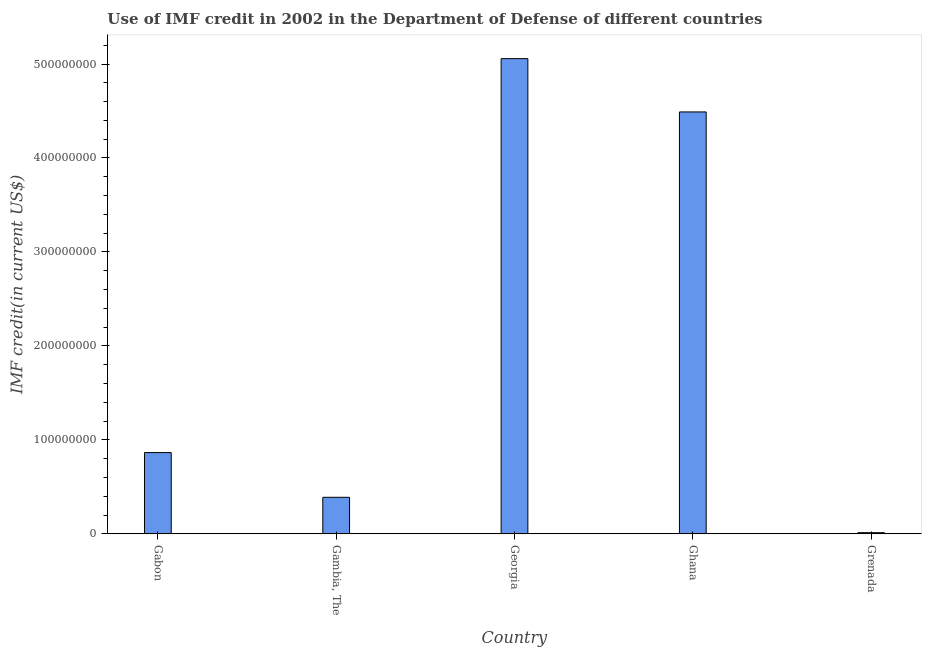Does the graph contain any zero values?
Make the answer very short. No. What is the title of the graph?
Give a very brief answer. Use of IMF credit in 2002 in the Department of Defense of different countries. What is the label or title of the X-axis?
Provide a succinct answer. Country. What is the label or title of the Y-axis?
Your answer should be compact. IMF credit(in current US$). What is the use of imf credit in dod in Grenada?
Provide a short and direct response. 1.26e+06. Across all countries, what is the maximum use of imf credit in dod?
Provide a short and direct response. 5.06e+08. Across all countries, what is the minimum use of imf credit in dod?
Your answer should be very brief. 1.26e+06. In which country was the use of imf credit in dod maximum?
Offer a terse response. Georgia. In which country was the use of imf credit in dod minimum?
Give a very brief answer. Grenada. What is the sum of the use of imf credit in dod?
Give a very brief answer. 1.08e+09. What is the difference between the use of imf credit in dod in Ghana and Grenada?
Make the answer very short. 4.48e+08. What is the average use of imf credit in dod per country?
Give a very brief answer. 2.16e+08. What is the median use of imf credit in dod?
Your answer should be compact. 8.65e+07. In how many countries, is the use of imf credit in dod greater than 320000000 US$?
Your response must be concise. 2. What is the ratio of the use of imf credit in dod in Gabon to that in Grenada?
Keep it short and to the point. 68.43. Is the use of imf credit in dod in Gabon less than that in Grenada?
Keep it short and to the point. No. What is the difference between the highest and the second highest use of imf credit in dod?
Provide a short and direct response. 5.67e+07. Is the sum of the use of imf credit in dod in Gambia, The and Ghana greater than the maximum use of imf credit in dod across all countries?
Your answer should be compact. No. What is the difference between the highest and the lowest use of imf credit in dod?
Provide a short and direct response. 5.04e+08. In how many countries, is the use of imf credit in dod greater than the average use of imf credit in dod taken over all countries?
Offer a terse response. 2. How many countries are there in the graph?
Give a very brief answer. 5. Are the values on the major ticks of Y-axis written in scientific E-notation?
Ensure brevity in your answer.  No. What is the IMF credit(in current US$) of Gabon?
Your answer should be compact. 8.65e+07. What is the IMF credit(in current US$) of Gambia, The?
Provide a short and direct response. 3.89e+07. What is the IMF credit(in current US$) of Georgia?
Ensure brevity in your answer.  5.06e+08. What is the IMF credit(in current US$) of Ghana?
Provide a succinct answer. 4.49e+08. What is the IMF credit(in current US$) in Grenada?
Your answer should be very brief. 1.26e+06. What is the difference between the IMF credit(in current US$) in Gabon and Gambia, The?
Provide a succinct answer. 4.76e+07. What is the difference between the IMF credit(in current US$) in Gabon and Georgia?
Offer a terse response. -4.19e+08. What is the difference between the IMF credit(in current US$) in Gabon and Ghana?
Provide a short and direct response. -3.63e+08. What is the difference between the IMF credit(in current US$) in Gabon and Grenada?
Ensure brevity in your answer.  8.52e+07. What is the difference between the IMF credit(in current US$) in Gambia, The and Georgia?
Provide a succinct answer. -4.67e+08. What is the difference between the IMF credit(in current US$) in Gambia, The and Ghana?
Provide a succinct answer. -4.10e+08. What is the difference between the IMF credit(in current US$) in Gambia, The and Grenada?
Give a very brief answer. 3.76e+07. What is the difference between the IMF credit(in current US$) in Georgia and Ghana?
Give a very brief answer. 5.67e+07. What is the difference between the IMF credit(in current US$) in Georgia and Grenada?
Offer a very short reply. 5.04e+08. What is the difference between the IMF credit(in current US$) in Ghana and Grenada?
Your response must be concise. 4.48e+08. What is the ratio of the IMF credit(in current US$) in Gabon to that in Gambia, The?
Provide a succinct answer. 2.22. What is the ratio of the IMF credit(in current US$) in Gabon to that in Georgia?
Ensure brevity in your answer.  0.17. What is the ratio of the IMF credit(in current US$) in Gabon to that in Ghana?
Ensure brevity in your answer.  0.19. What is the ratio of the IMF credit(in current US$) in Gabon to that in Grenada?
Your answer should be compact. 68.43. What is the ratio of the IMF credit(in current US$) in Gambia, The to that in Georgia?
Ensure brevity in your answer.  0.08. What is the ratio of the IMF credit(in current US$) in Gambia, The to that in Ghana?
Make the answer very short. 0.09. What is the ratio of the IMF credit(in current US$) in Gambia, The to that in Grenada?
Your response must be concise. 30.78. What is the ratio of the IMF credit(in current US$) in Georgia to that in Ghana?
Your response must be concise. 1.13. What is the ratio of the IMF credit(in current US$) in Georgia to that in Grenada?
Offer a very short reply. 400.1. What is the ratio of the IMF credit(in current US$) in Ghana to that in Grenada?
Ensure brevity in your answer.  355.23. 